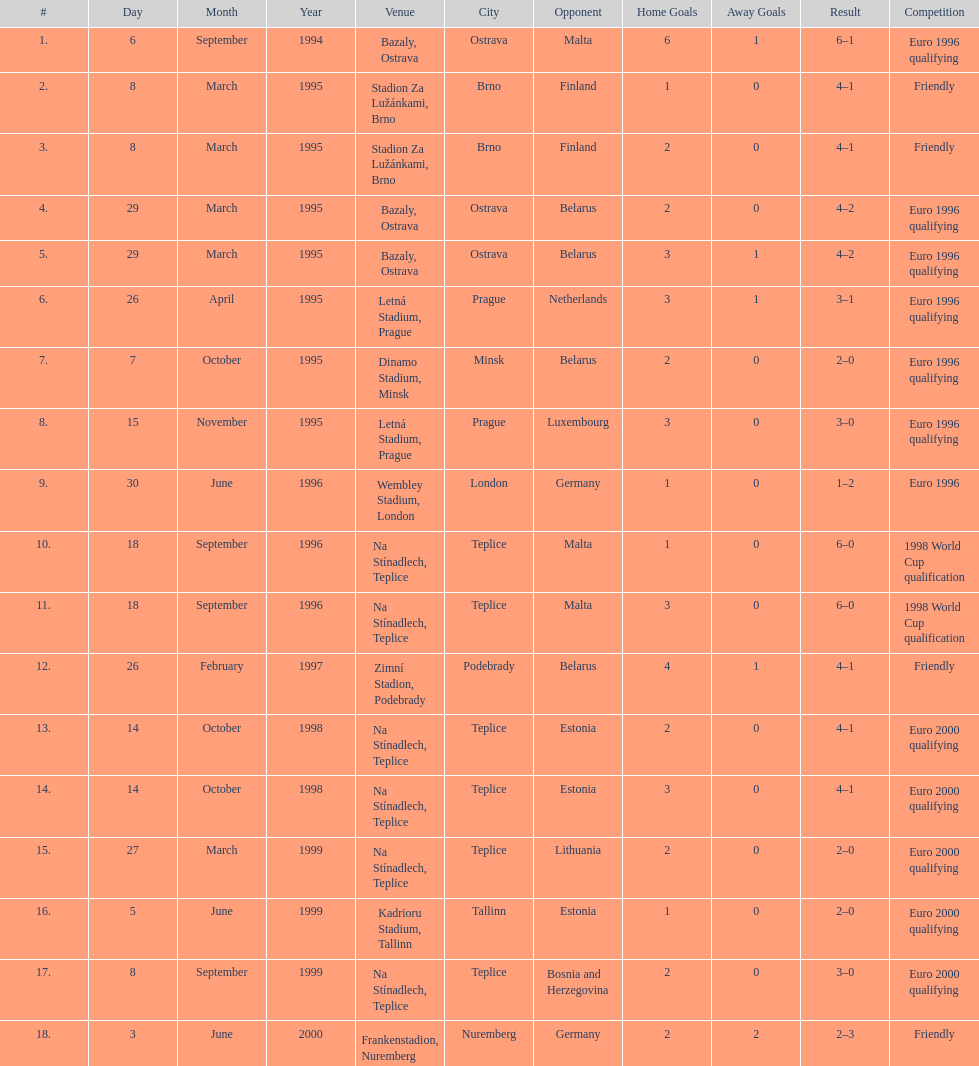List the opponents which are under the friendly competition. Finland, Belarus, Germany. 